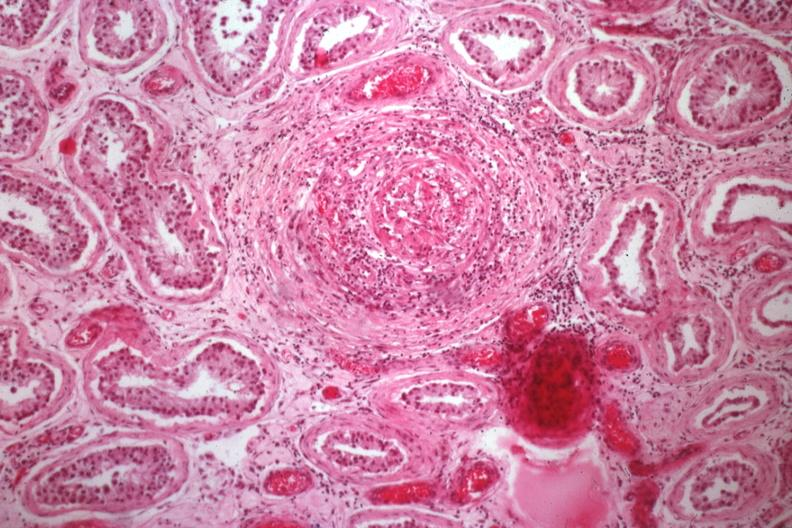s testicle present?
Answer the question using a single word or phrase. Yes 